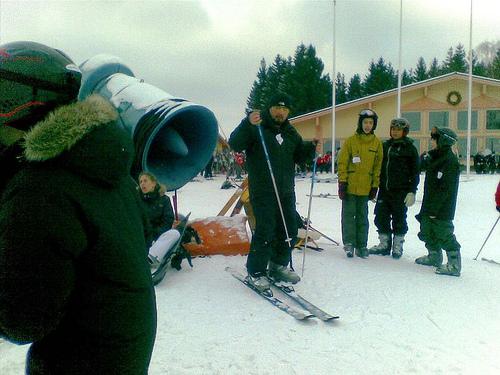Is this an outdoor concert?
Be succinct. No. Where is the building?
Short answer required. Behind people. How many people are wearing green?
Write a very short answer. 3. What type of boots are the people wearing?
Short answer required. Snow. 